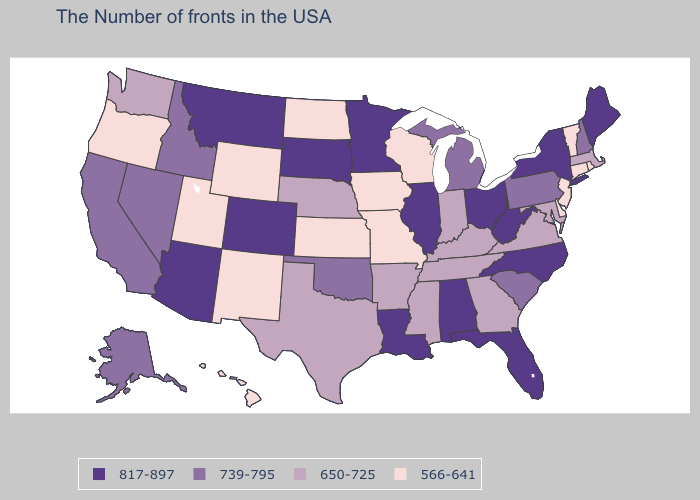Among the states that border Texas , does Oklahoma have the highest value?
Short answer required. No. Which states have the highest value in the USA?
Write a very short answer. Maine, New York, North Carolina, West Virginia, Ohio, Florida, Alabama, Illinois, Louisiana, Minnesota, South Dakota, Colorado, Montana, Arizona. Which states hav the highest value in the MidWest?
Concise answer only. Ohio, Illinois, Minnesota, South Dakota. What is the value of Alabama?
Answer briefly. 817-897. Name the states that have a value in the range 650-725?
Quick response, please. Massachusetts, Maryland, Virginia, Georgia, Kentucky, Indiana, Tennessee, Mississippi, Arkansas, Nebraska, Texas, Washington. What is the value of Maryland?
Give a very brief answer. 650-725. Does North Dakota have a lower value than Hawaii?
Short answer required. No. Does Oklahoma have the lowest value in the USA?
Be succinct. No. What is the lowest value in states that border Florida?
Keep it brief. 650-725. What is the value of Alaska?
Short answer required. 739-795. What is the lowest value in states that border Indiana?
Be succinct. 650-725. What is the lowest value in the MidWest?
Short answer required. 566-641. Name the states that have a value in the range 817-897?
Give a very brief answer. Maine, New York, North Carolina, West Virginia, Ohio, Florida, Alabama, Illinois, Louisiana, Minnesota, South Dakota, Colorado, Montana, Arizona. What is the value of Massachusetts?
Give a very brief answer. 650-725. 